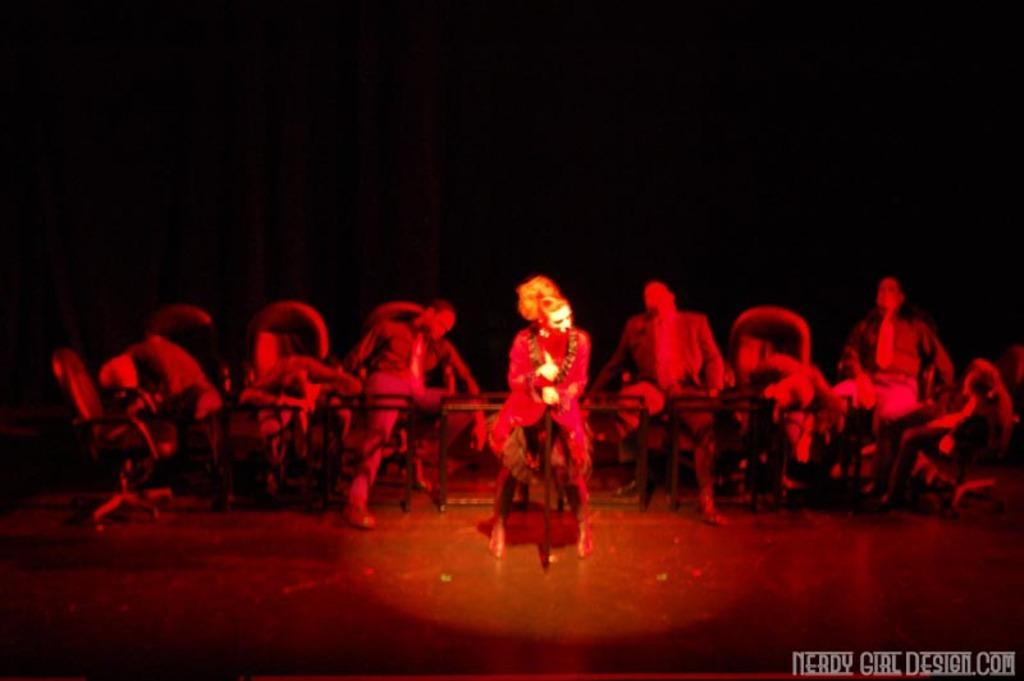Who is present in the image? There are people in the image. Can you describe the attire of one of the individuals? The person wearing a red color dress is in the image. How would you describe the lighting in the image? The image is slightly dark. What type of chess move is being made by the person in the red dress? There is no chess game or move present in the image; it features people, including one wearing a red dress. What health advice is being given by the person in the red dress? There is no health advice or discussion present in the image; it focuses on the presence of people and their attire. 